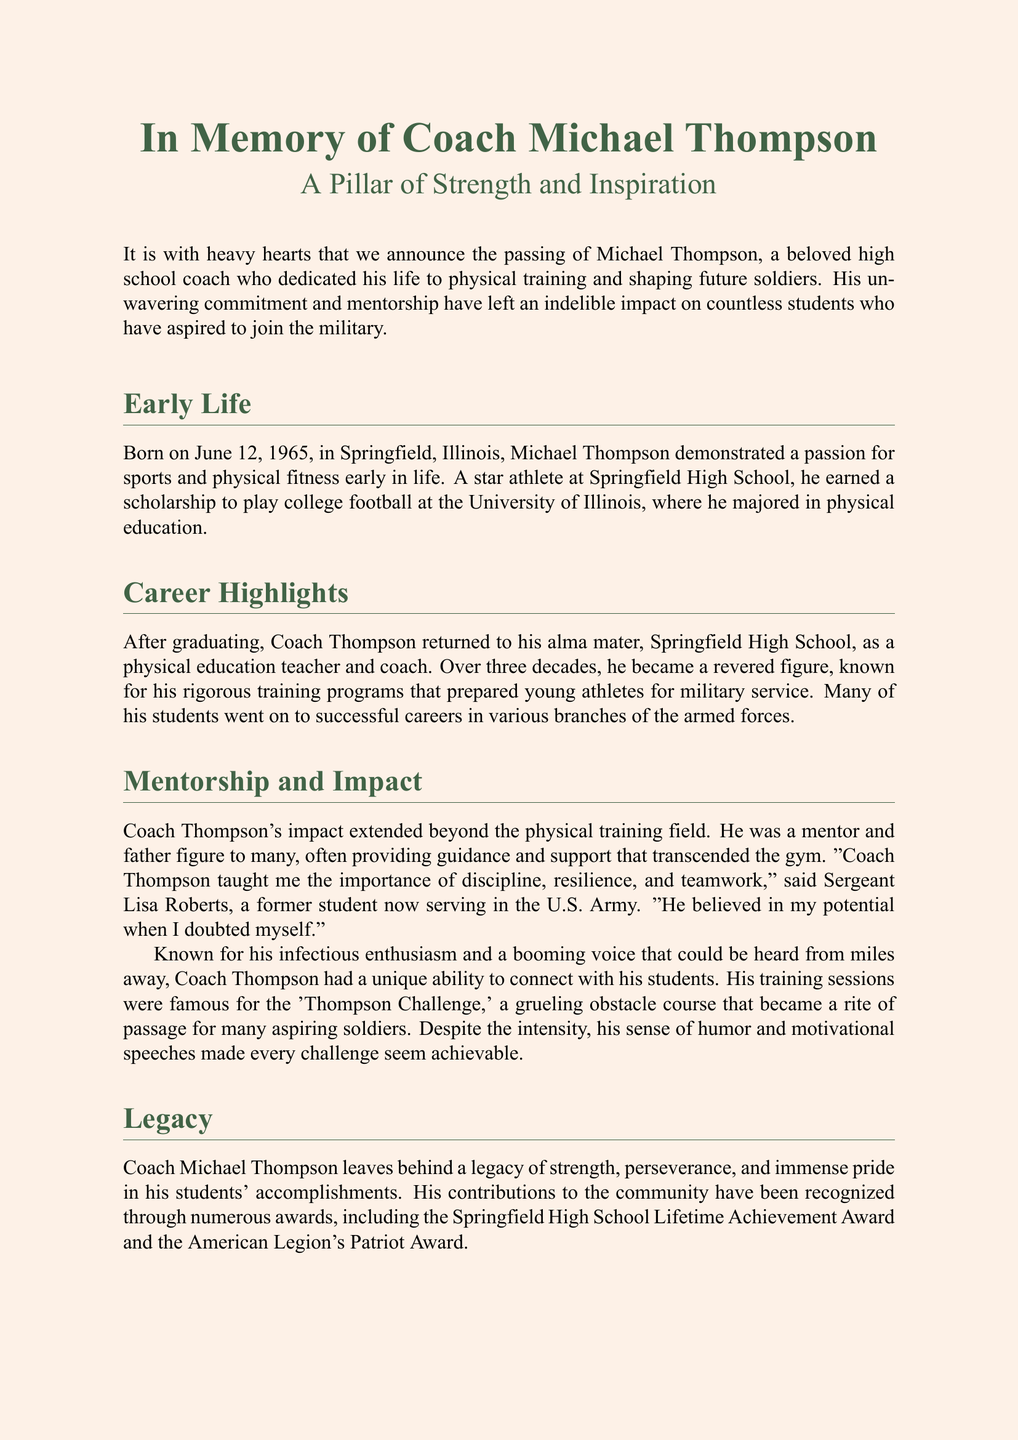What is the name of the coach? The document states the coach's name is Michael Thompson.
Answer: Michael Thompson When was Coach Thompson born? The document specifies that Coach Thompson was born on June 12, 1965.
Answer: June 12, 1965 What prestigious award did Coach Thompson receive from the American Legion? The document notes that he received the American Legion’s Patriot Award.
Answer: Patriot Award How many decades did Coach Thompson serve at Springfield High School? The document mentions that he served for over three decades.
Answer: Three decades What was the name of the hard training course he created? The document refers to it as the 'Thompson Challenge.'
Answer: Thompson Challenge Who is quoted in the obituary as a former student? The document mentions Sergeant Lisa Roberts as the quoted former student.
Answer: Sergeant Lisa Roberts Where will the memorial service be held? The document states the memorial service will be at Springfield High School gymnasium.
Answer: Springfield High School gymnasium In which field did Coach Thompson major during college? The document indicates that he majored in physical education.
Answer: Physical education What is the purpose of the Coach Thompson Scholarship Fund? The document states it supports students aspiring to join the military.
Answer: Supporting students aspiring to join the military 